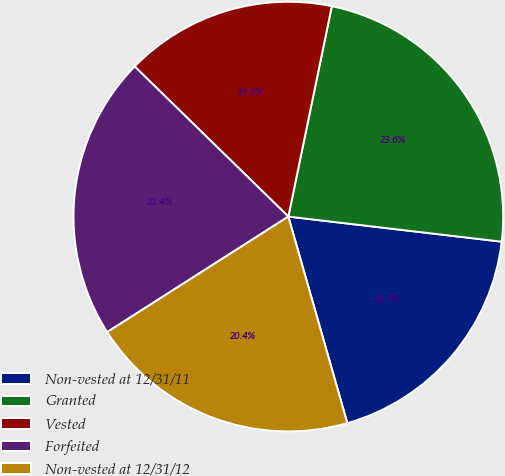<chart> <loc_0><loc_0><loc_500><loc_500><pie_chart><fcel>Non-vested at 12/31/11<fcel>Granted<fcel>Vested<fcel>Forfeited<fcel>Non-vested at 12/31/12<nl><fcel>18.71%<fcel>23.62%<fcel>15.93%<fcel>21.35%<fcel>20.39%<nl></chart> 